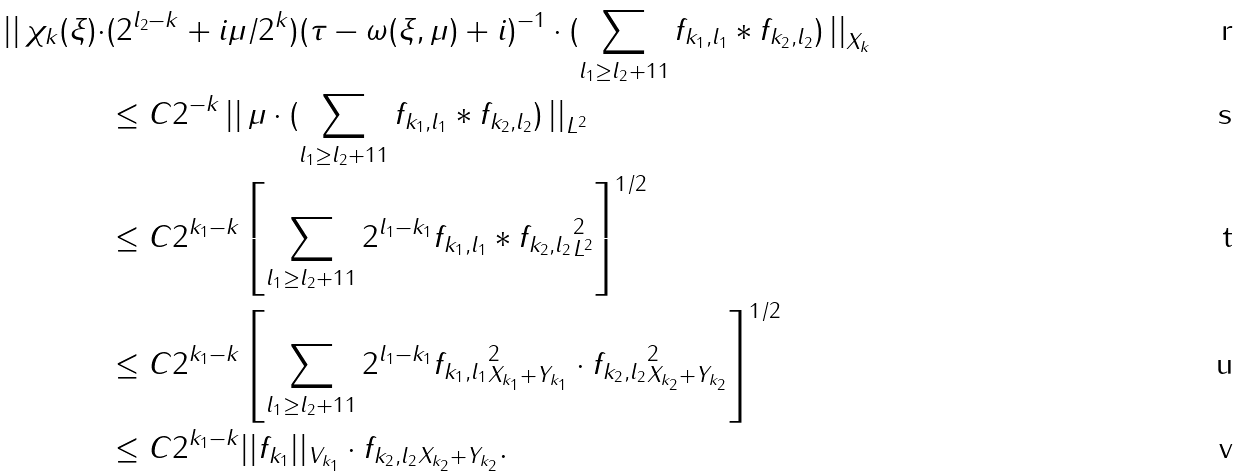Convert formula to latex. <formula><loc_0><loc_0><loc_500><loc_500>\left | \right | \chi _ { k } ( \xi ) \cdot & ( 2 ^ { l _ { 2 } - k } + i \mu / 2 ^ { k } ) ( \tau - \omega ( \xi , \mu ) + i ) ^ { - 1 } \cdot ( \sum _ { l _ { 1 } \geq l _ { 2 } + 1 1 } f _ { k _ { 1 } , l _ { 1 } } \ast f _ { k _ { 2 } , l _ { 2 } } ) \left | \right | _ { X _ { k } } \\ & \leq C 2 ^ { - k } \left | \right | \mu \cdot ( \sum _ { l _ { 1 } \geq l _ { 2 } + 1 1 } f _ { k _ { 1 } , l _ { 1 } } \ast f _ { k _ { 2 } , l _ { 2 } } ) \left | \right | _ { L ^ { 2 } } \\ & \leq C 2 ^ { k _ { 1 } - k } \left [ \sum _ { l _ { 1 } \geq l _ { 2 } + 1 1 } \| 2 ^ { l _ { 1 } - k _ { 1 } } f _ { k _ { 1 } , l _ { 1 } } \ast f _ { k _ { 2 } , l _ { 2 } } \| _ { L ^ { 2 } } ^ { 2 } \right ] ^ { 1 / 2 } \\ & \leq C 2 ^ { k _ { 1 } - k } \left [ \sum _ { l _ { 1 } \geq l _ { 2 } + 1 1 } \| 2 ^ { l _ { 1 } - k _ { 1 } } f _ { k _ { 1 } , l _ { 1 } } \| _ { X _ { k _ { 1 } } + Y _ { k _ { 1 } } } ^ { 2 } \cdot \| f _ { k _ { 2 } , l _ { 2 } } \| _ { X _ { k _ { 2 } } + Y _ { k _ { 2 } } } ^ { 2 } \right ] ^ { 1 / 2 } \\ & \leq C 2 ^ { k _ { 1 } - k } | | f _ { k _ { 1 } } | | _ { V _ { k _ { 1 } } } \cdot \| f _ { k _ { 2 } , l _ { 2 } } \| _ { X _ { k _ { 2 } } + Y _ { k _ { 2 } } } .</formula> 